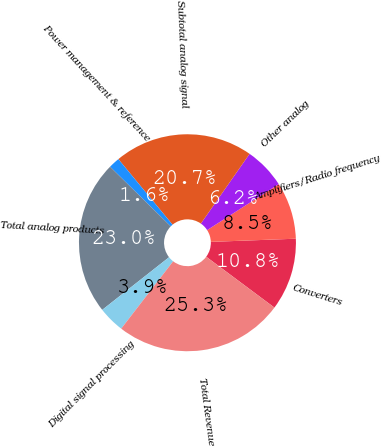Convert chart to OTSL. <chart><loc_0><loc_0><loc_500><loc_500><pie_chart><fcel>Converters<fcel>Amplifiers/Radio frequency<fcel>Other analog<fcel>Subtotal analog signal<fcel>Power management & reference<fcel>Total analog products<fcel>Digital signal processing<fcel>Total Revenue<nl><fcel>10.79%<fcel>8.49%<fcel>6.21%<fcel>20.7%<fcel>1.65%<fcel>22.98%<fcel>3.93%<fcel>25.26%<nl></chart> 